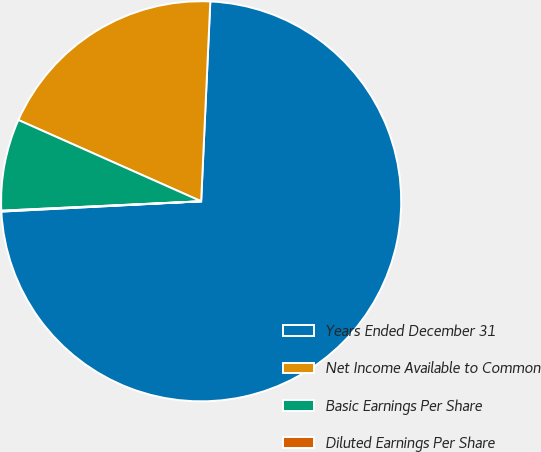Convert chart. <chart><loc_0><loc_0><loc_500><loc_500><pie_chart><fcel>Years Ended December 31<fcel>Net Income Available to Common<fcel>Basic Earnings Per Share<fcel>Diluted Earnings Per Share<nl><fcel>73.46%<fcel>19.07%<fcel>7.41%<fcel>0.07%<nl></chart> 